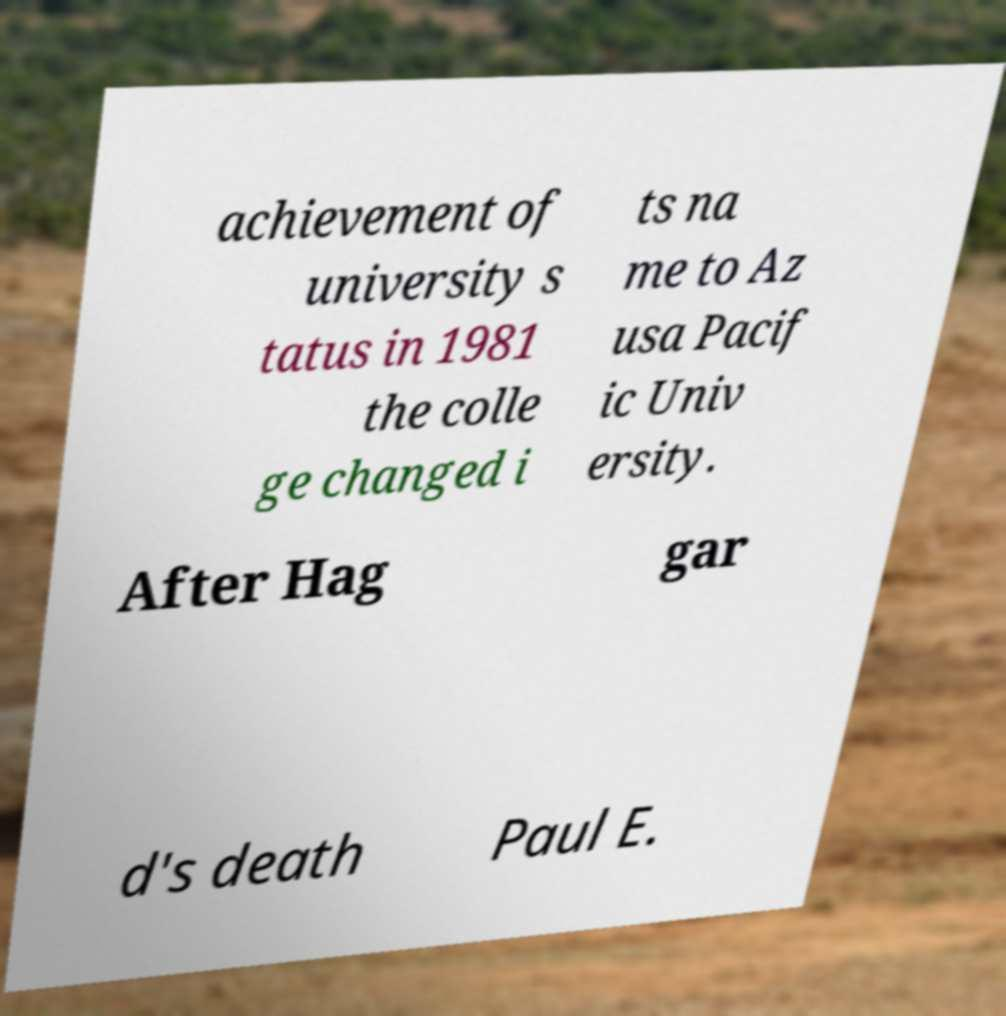There's text embedded in this image that I need extracted. Can you transcribe it verbatim? achievement of university s tatus in 1981 the colle ge changed i ts na me to Az usa Pacif ic Univ ersity. After Hag gar d's death Paul E. 